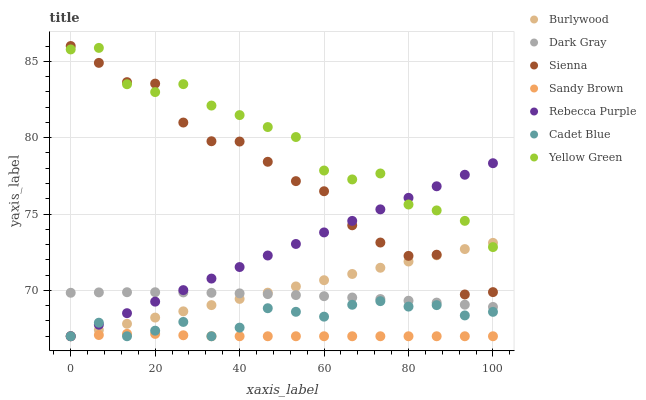Does Sandy Brown have the minimum area under the curve?
Answer yes or no. Yes. Does Yellow Green have the maximum area under the curve?
Answer yes or no. Yes. Does Cadet Blue have the minimum area under the curve?
Answer yes or no. No. Does Cadet Blue have the maximum area under the curve?
Answer yes or no. No. Is Burlywood the smoothest?
Answer yes or no. Yes. Is Yellow Green the roughest?
Answer yes or no. Yes. Is Cadet Blue the smoothest?
Answer yes or no. No. Is Cadet Blue the roughest?
Answer yes or no. No. Does Cadet Blue have the lowest value?
Answer yes or no. Yes. Does Yellow Green have the lowest value?
Answer yes or no. No. Does Sienna have the highest value?
Answer yes or no. Yes. Does Cadet Blue have the highest value?
Answer yes or no. No. Is Dark Gray less than Yellow Green?
Answer yes or no. Yes. Is Yellow Green greater than Cadet Blue?
Answer yes or no. Yes. Does Rebecca Purple intersect Yellow Green?
Answer yes or no. Yes. Is Rebecca Purple less than Yellow Green?
Answer yes or no. No. Is Rebecca Purple greater than Yellow Green?
Answer yes or no. No. Does Dark Gray intersect Yellow Green?
Answer yes or no. No. 